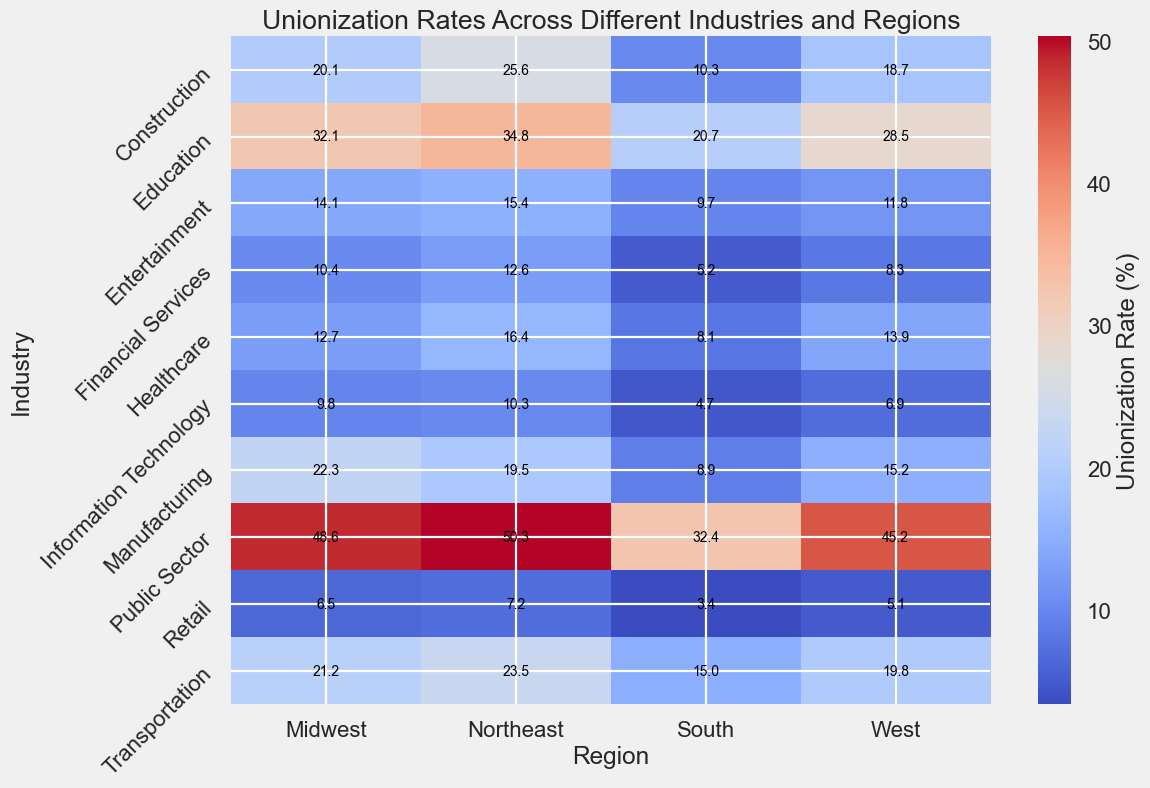Which industry in the Northeast has the highest unionization rate? The highest unionization rate in the Northeast can be found by visually inspecting the darkest shade on the heatmap in this region's column. The darkest shade corresponds to "Public Sector" with a rate of 50.3%.
Answer: Public Sector What is the difference in unionization rates between the Construction industry in the Northeast and the South? The unionization rate for Construction in the Northeast is 25.6% and in the South is 10.3%. The difference is calculated as 25.6% - 10.3% = 15.3%.
Answer: 15.3% Which region has the lowest unionization rate for the Information Technology industry? The lowest unionization rate for the Information Technology industry can be found by identifying the lightest shade in that row. The South region has a unionization rate of 4.7%, which is the lowest.
Answer: South How does the unionization rate in the Education industry in the Midwest compare to that in the West? By comparing the shades of color in the Education industry row, the Midwest has a unionization rate of 32.1% while the West has 28.5%. Therefore, the rate in the Midwest is higher.
Answer: Midwest What is the average unionization rate for the Manufacturing industry across all regions? To calculate the average, sum the unionization rates for Manufacturing across all regions and divide by the number of regions: (19.5 + 22.3 + 8.9 + 15.2) / 4 = 65.9 / 4 = 16.475%.
Answer: 16.5% Which region shows the highest unionization rate overall? To find the region with the highest unionization rate, compare the darkest shades across all rows for each region column. The Northeast Public Sector with 50.3% is the highest.
Answer: Northeast Does the Healthcare industry in the Northeast have a higher unionization rate compared to the South? By examining the heatmap, the Northeast Healthcare unionization rate is 16.4% while in the South it is 8.1%, so the Northeast has a higher rate.
Answer: Northeast What is the sum of unionization rates for the Public Sector in the Midwest and the West? Add the unionization rates for the Public Sector in both regions: 48.6% (Midwest) + 45.2% (West) = 93.8%.
Answer: 93.8% Which industry in the West has the lowest unionization rate, and what is that rate? By inspecting the lightest shade in the West column, Information Technology is the industry with the lowest unionization rate at 6.9%.
Answer: Information Technology, 6.9% How does the unionization rate of Financial Services in the Northeast compare to that in the Midwest? By comparing the color shades in the Financial Services row, the Northeast has a rate of 12.6%, whereas the Midwest has 10.4%. Thus, the rate in the Northeast is higher.
Answer: Northeast 